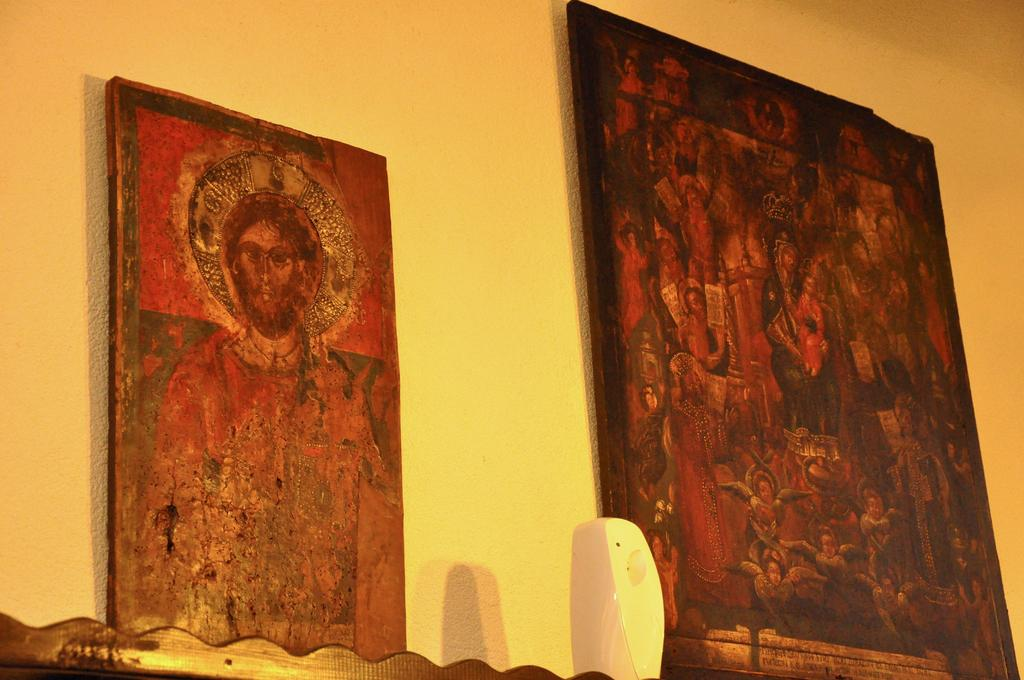How many photo frames are visible in the image? There are two photo frames in the image. Where are the photo frames located? The photo frames are on the wall. Is there a kite being flown in the image? No, there is no kite present in the image. Is there an event taking place in the image? The provided facts do not mention any event taking place in the image. 